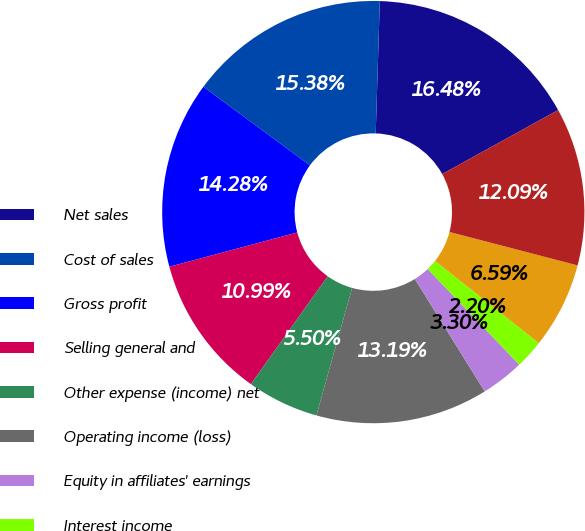Convert chart. <chart><loc_0><loc_0><loc_500><loc_500><pie_chart><fcel>Net sales<fcel>Cost of sales<fcel>Gross profit<fcel>Selling general and<fcel>Other expense (income) net<fcel>Operating income (loss)<fcel>Equity in affiliates' earnings<fcel>Interest income<fcel>Interest expense and finance<fcel>Earnings (loss) before income<nl><fcel>16.48%<fcel>15.38%<fcel>14.28%<fcel>10.99%<fcel>5.5%<fcel>13.19%<fcel>3.3%<fcel>2.2%<fcel>6.59%<fcel>12.09%<nl></chart> 